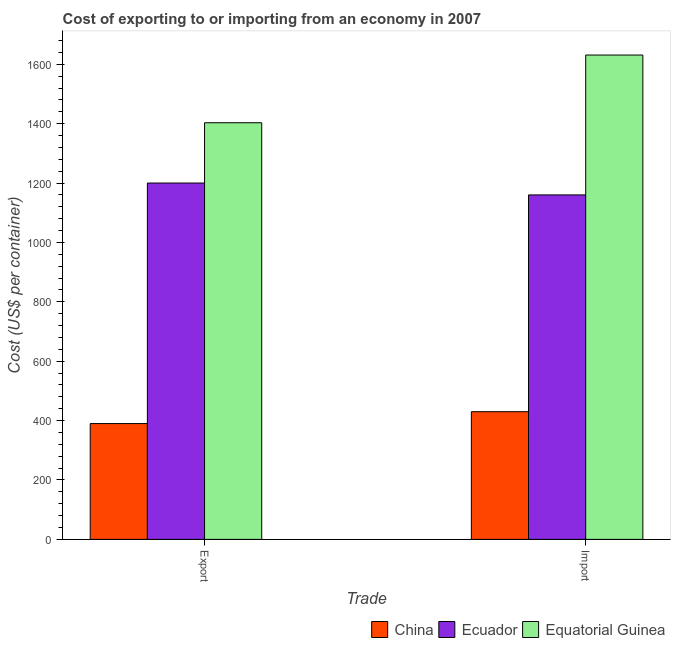How many different coloured bars are there?
Offer a very short reply. 3. How many bars are there on the 1st tick from the right?
Give a very brief answer. 3. What is the label of the 2nd group of bars from the left?
Ensure brevity in your answer.  Import. What is the import cost in China?
Offer a terse response. 430. Across all countries, what is the maximum import cost?
Ensure brevity in your answer.  1631. Across all countries, what is the minimum export cost?
Keep it short and to the point. 390. In which country was the import cost maximum?
Your answer should be very brief. Equatorial Guinea. In which country was the import cost minimum?
Your response must be concise. China. What is the total import cost in the graph?
Offer a very short reply. 3221. What is the difference between the import cost in Ecuador and that in Equatorial Guinea?
Your response must be concise. -471. What is the difference between the import cost in China and the export cost in Equatorial Guinea?
Provide a short and direct response. -973. What is the average import cost per country?
Keep it short and to the point. 1073.67. What is the difference between the export cost and import cost in Ecuador?
Offer a terse response. 40. In how many countries, is the export cost greater than 1600 US$?
Your response must be concise. 0. What is the ratio of the export cost in China to that in Equatorial Guinea?
Provide a short and direct response. 0.28. What does the 3rd bar from the left in Import represents?
Give a very brief answer. Equatorial Guinea. How many bars are there?
Provide a short and direct response. 6. Does the graph contain grids?
Provide a succinct answer. No. Where does the legend appear in the graph?
Your answer should be compact. Bottom right. How many legend labels are there?
Give a very brief answer. 3. What is the title of the graph?
Provide a succinct answer. Cost of exporting to or importing from an economy in 2007. What is the label or title of the X-axis?
Give a very brief answer. Trade. What is the label or title of the Y-axis?
Your answer should be very brief. Cost (US$ per container). What is the Cost (US$ per container) of China in Export?
Your answer should be compact. 390. What is the Cost (US$ per container) of Ecuador in Export?
Ensure brevity in your answer.  1200. What is the Cost (US$ per container) in Equatorial Guinea in Export?
Keep it short and to the point. 1403. What is the Cost (US$ per container) of China in Import?
Your answer should be compact. 430. What is the Cost (US$ per container) in Ecuador in Import?
Offer a very short reply. 1160. What is the Cost (US$ per container) of Equatorial Guinea in Import?
Offer a terse response. 1631. Across all Trade, what is the maximum Cost (US$ per container) of China?
Make the answer very short. 430. Across all Trade, what is the maximum Cost (US$ per container) of Ecuador?
Provide a short and direct response. 1200. Across all Trade, what is the maximum Cost (US$ per container) of Equatorial Guinea?
Your answer should be compact. 1631. Across all Trade, what is the minimum Cost (US$ per container) of China?
Make the answer very short. 390. Across all Trade, what is the minimum Cost (US$ per container) of Ecuador?
Offer a terse response. 1160. Across all Trade, what is the minimum Cost (US$ per container) of Equatorial Guinea?
Your response must be concise. 1403. What is the total Cost (US$ per container) of China in the graph?
Your answer should be compact. 820. What is the total Cost (US$ per container) of Ecuador in the graph?
Give a very brief answer. 2360. What is the total Cost (US$ per container) in Equatorial Guinea in the graph?
Offer a very short reply. 3034. What is the difference between the Cost (US$ per container) in Equatorial Guinea in Export and that in Import?
Ensure brevity in your answer.  -228. What is the difference between the Cost (US$ per container) of China in Export and the Cost (US$ per container) of Ecuador in Import?
Offer a very short reply. -770. What is the difference between the Cost (US$ per container) in China in Export and the Cost (US$ per container) in Equatorial Guinea in Import?
Your response must be concise. -1241. What is the difference between the Cost (US$ per container) of Ecuador in Export and the Cost (US$ per container) of Equatorial Guinea in Import?
Your answer should be very brief. -431. What is the average Cost (US$ per container) in China per Trade?
Your answer should be compact. 410. What is the average Cost (US$ per container) of Ecuador per Trade?
Ensure brevity in your answer.  1180. What is the average Cost (US$ per container) of Equatorial Guinea per Trade?
Give a very brief answer. 1517. What is the difference between the Cost (US$ per container) of China and Cost (US$ per container) of Ecuador in Export?
Keep it short and to the point. -810. What is the difference between the Cost (US$ per container) of China and Cost (US$ per container) of Equatorial Guinea in Export?
Make the answer very short. -1013. What is the difference between the Cost (US$ per container) of Ecuador and Cost (US$ per container) of Equatorial Guinea in Export?
Your answer should be very brief. -203. What is the difference between the Cost (US$ per container) of China and Cost (US$ per container) of Ecuador in Import?
Your answer should be very brief. -730. What is the difference between the Cost (US$ per container) in China and Cost (US$ per container) in Equatorial Guinea in Import?
Your answer should be compact. -1201. What is the difference between the Cost (US$ per container) in Ecuador and Cost (US$ per container) in Equatorial Guinea in Import?
Your response must be concise. -471. What is the ratio of the Cost (US$ per container) in China in Export to that in Import?
Your answer should be very brief. 0.91. What is the ratio of the Cost (US$ per container) of Ecuador in Export to that in Import?
Your response must be concise. 1.03. What is the ratio of the Cost (US$ per container) of Equatorial Guinea in Export to that in Import?
Provide a short and direct response. 0.86. What is the difference between the highest and the second highest Cost (US$ per container) in Equatorial Guinea?
Your response must be concise. 228. What is the difference between the highest and the lowest Cost (US$ per container) in Ecuador?
Offer a terse response. 40. What is the difference between the highest and the lowest Cost (US$ per container) of Equatorial Guinea?
Your answer should be very brief. 228. 